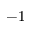Convert formula to latex. <formula><loc_0><loc_0><loc_500><loc_500>- 1</formula> 